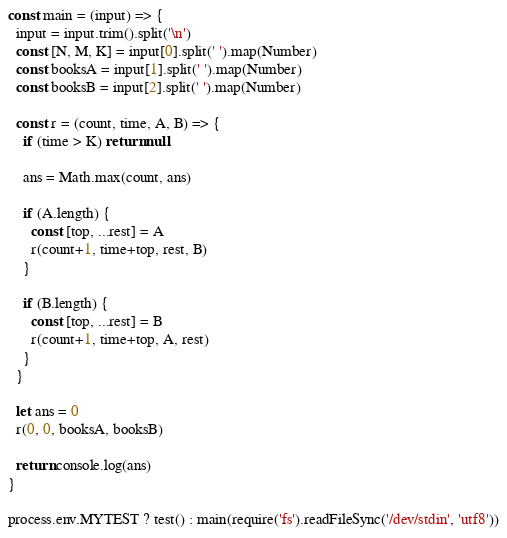Convert code to text. <code><loc_0><loc_0><loc_500><loc_500><_JavaScript_>const main = (input) => {
  input = input.trim().split('\n')
  const [N, M, K] = input[0].split(' ').map(Number)
  const booksA = input[1].split(' ').map(Number)
  const booksB = input[2].split(' ').map(Number)

  const r = (count, time, A, B) => {
    if (time > K) return null

    ans = Math.max(count, ans)

    if (A.length) {
      const [top, ...rest] = A
      r(count+1, time+top, rest, B)
    }

    if (B.length) {
      const [top, ...rest] = B
      r(count+1, time+top, A, rest)
    }
  }

  let ans = 0
  r(0, 0, booksA, booksB)

  return console.log(ans)
}

process.env.MYTEST ? test() : main(require('fs').readFileSync('/dev/stdin', 'utf8'))</code> 